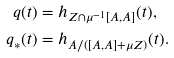<formula> <loc_0><loc_0><loc_500><loc_500>q ( t ) & = h _ { Z \cap \mu ^ { - 1 } [ A , A ] } ( t ) , \\ q _ { * } ( t ) & = h _ { A / ( [ A , A ] + \mu Z ) } ( t ) .</formula> 